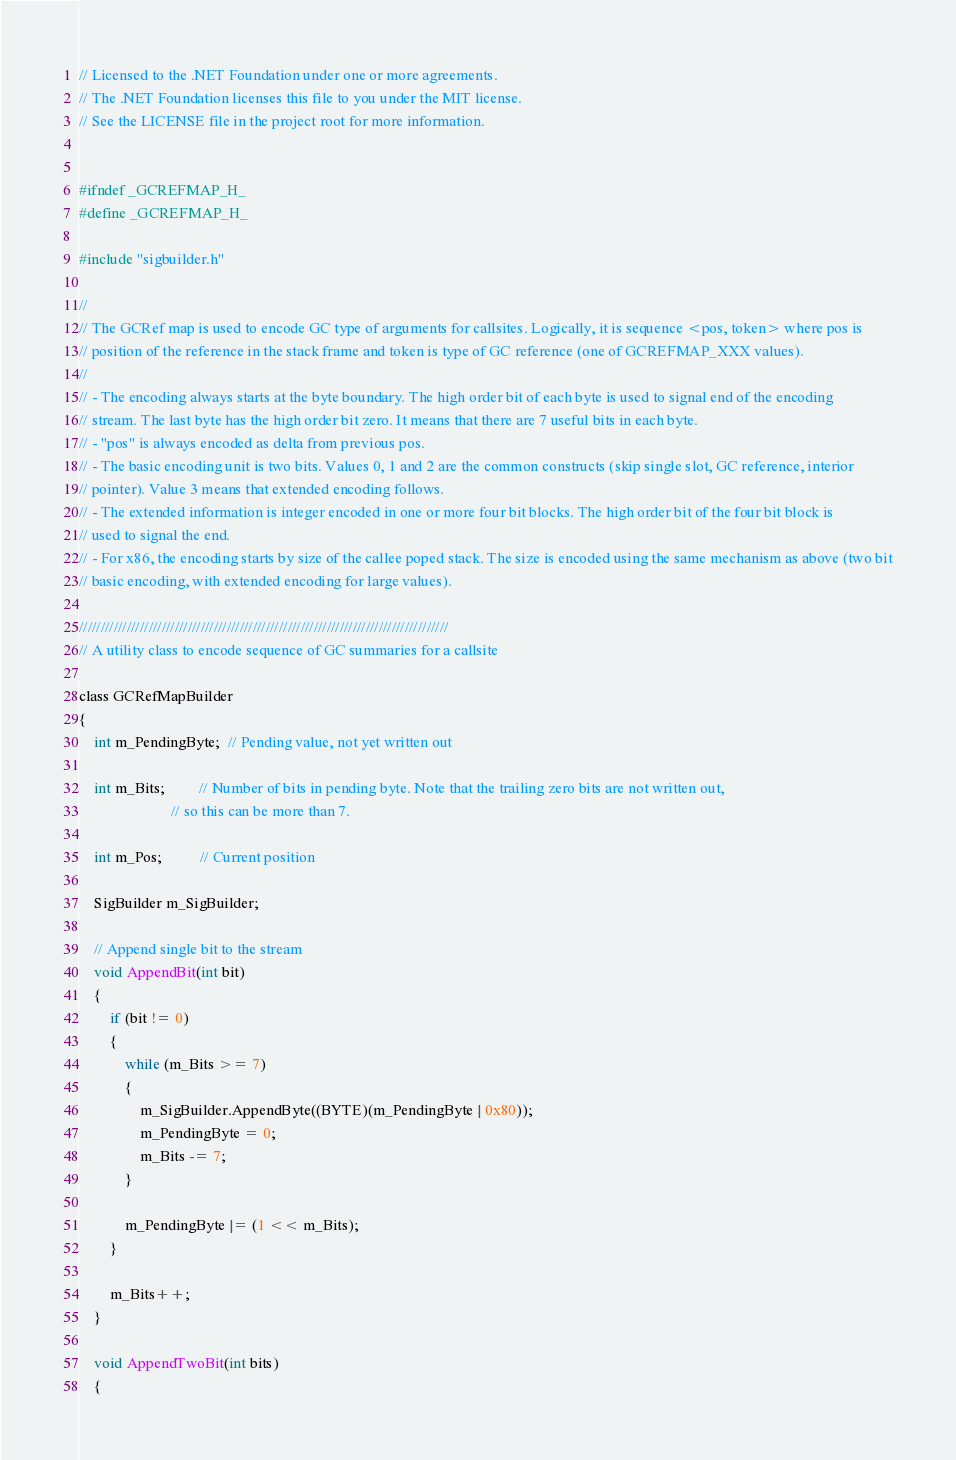Convert code to text. <code><loc_0><loc_0><loc_500><loc_500><_C_>// Licensed to the .NET Foundation under one or more agreements.
// The .NET Foundation licenses this file to you under the MIT license.
// See the LICENSE file in the project root for more information.


#ifndef _GCREFMAP_H_
#define _GCREFMAP_H_

#include "sigbuilder.h"

//
// The GCRef map is used to encode GC type of arguments for callsites. Logically, it is sequence <pos, token> where pos is
// position of the reference in the stack frame and token is type of GC reference (one of GCREFMAP_XXX values).
//
// - The encoding always starts at the byte boundary. The high order bit of each byte is used to signal end of the encoding
// stream. The last byte has the high order bit zero. It means that there are 7 useful bits in each byte.
// - "pos" is always encoded as delta from previous pos.
// - The basic encoding unit is two bits. Values 0, 1 and 2 are the common constructs (skip single slot, GC reference, interior
// pointer). Value 3 means that extended encoding follows.
// - The extended information is integer encoded in one or more four bit blocks. The high order bit of the four bit block is
// used to signal the end.
// - For x86, the encoding starts by size of the callee poped stack. The size is encoded using the same mechanism as above (two bit
// basic encoding, with extended encoding for large values).

/////////////////////////////////////////////////////////////////////////////////////
// A utility class to encode sequence of GC summaries for a callsite

class GCRefMapBuilder
{
    int m_PendingByte;  // Pending value, not yet written out

    int m_Bits;         // Number of bits in pending byte. Note that the trailing zero bits are not written out,
                        // so this can be more than 7.

    int m_Pos;          // Current position

    SigBuilder m_SigBuilder;

    // Append single bit to the stream
    void AppendBit(int bit)
    {
        if (bit != 0)
        {
            while (m_Bits >= 7)
            {
                m_SigBuilder.AppendByte((BYTE)(m_PendingByte | 0x80));
                m_PendingByte = 0;
                m_Bits -= 7;
            }

            m_PendingByte |= (1 << m_Bits);
        }

        m_Bits++;
    }

    void AppendTwoBit(int bits)
    {</code> 